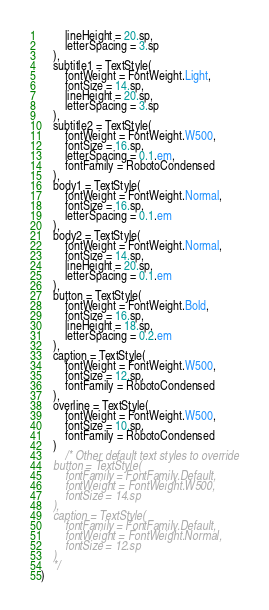Convert code to text. <code><loc_0><loc_0><loc_500><loc_500><_Kotlin_>        lineHeight = 20.sp,
        letterSpacing = 3.sp
    ),
    subtitle1 = TextStyle(
        fontWeight = FontWeight.Light,
        fontSize = 14.sp,
        lineHeight = 20.sp,
        letterSpacing = 3.sp
    ),
    subtitle2 = TextStyle(
        fontWeight = FontWeight.W500,
        fontSize = 16.sp,
        letterSpacing = 0.1.em,
        fontFamily = RobotoCondensed
    ),
    body1 = TextStyle(
        fontWeight = FontWeight.Normal,
        fontSize = 16.sp,
        letterSpacing = 0.1.em
    ),
    body2 = TextStyle(
        fontWeight = FontWeight.Normal,
        fontSize = 14.sp,
        lineHeight = 20.sp,
        letterSpacing = 0.1.em
    ),
    button = TextStyle(
        fontWeight = FontWeight.Bold,
        fontSize = 16.sp,
        lineHeight = 18.sp,
        letterSpacing = 0.2.em
    ),
    caption = TextStyle(
        fontWeight = FontWeight.W500,
        fontSize = 12.sp,
        fontFamily = RobotoCondensed
    ),
    overline = TextStyle(
        fontWeight = FontWeight.W500,
        fontSize = 10.sp,
        fontFamily = RobotoCondensed
    )
        /* Other default text styles to override
    button = TextStyle(
        fontFamily = FontFamily.Default,
        fontWeight = FontWeight.W500,
        fontSize = 14.sp
    ),
    caption = TextStyle(
        fontFamily = FontFamily.Default,
        fontWeight = FontWeight.Normal,
        fontSize = 12.sp
    )
    */
)
</code> 